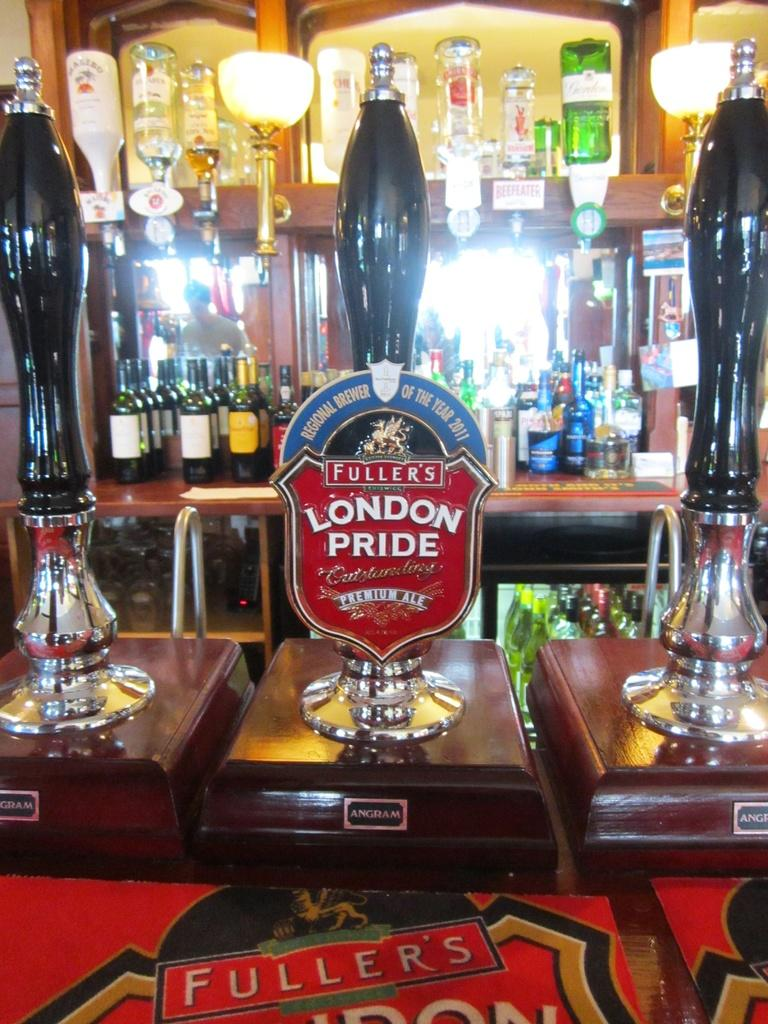What is the main subject of the image? The main subject of the image is many bottles arranged on a shelf. What else can be seen in the image besides the bottles? There are three awards visible in the image. What is the background of the image like? Some lights can be seen in the background of the image. What type of feeling does the owl in the image express? There is no owl present in the image, so it is not possible to determine the feeling it might express. 